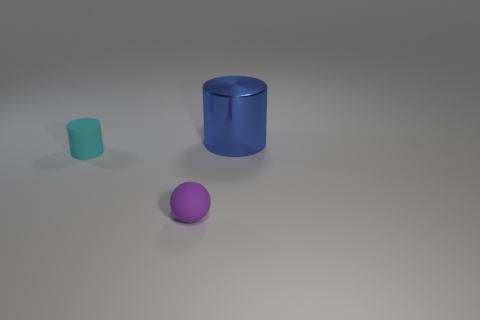Add 1 metallic objects. How many objects exist? 4 Subtract all cylinders. How many objects are left? 1 Subtract 1 cylinders. How many cylinders are left? 1 Add 1 small purple rubber balls. How many small purple rubber balls exist? 2 Subtract 0 gray blocks. How many objects are left? 3 Subtract all small gray shiny cylinders. Subtract all cyan matte objects. How many objects are left? 2 Add 2 shiny objects. How many shiny objects are left? 3 